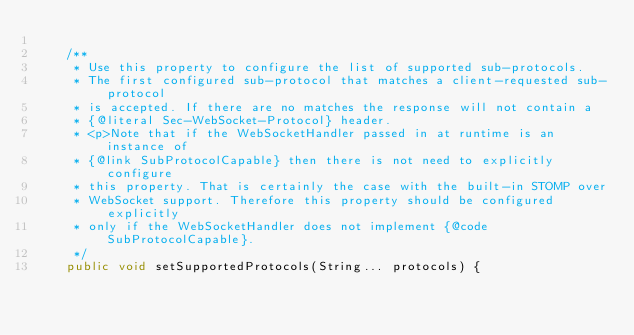<code> <loc_0><loc_0><loc_500><loc_500><_Java_>
	/**
	 * Use this property to configure the list of supported sub-protocols.
	 * The first configured sub-protocol that matches a client-requested sub-protocol
	 * is accepted. If there are no matches the response will not contain a
	 * {@literal Sec-WebSocket-Protocol} header.
	 * <p>Note that if the WebSocketHandler passed in at runtime is an instance of
	 * {@link SubProtocolCapable} then there is not need to explicitly configure
	 * this property. That is certainly the case with the built-in STOMP over
	 * WebSocket support. Therefore this property should be configured explicitly
	 * only if the WebSocketHandler does not implement {@code SubProtocolCapable}.
	 */
	public void setSupportedProtocols(String... protocols) {</code> 